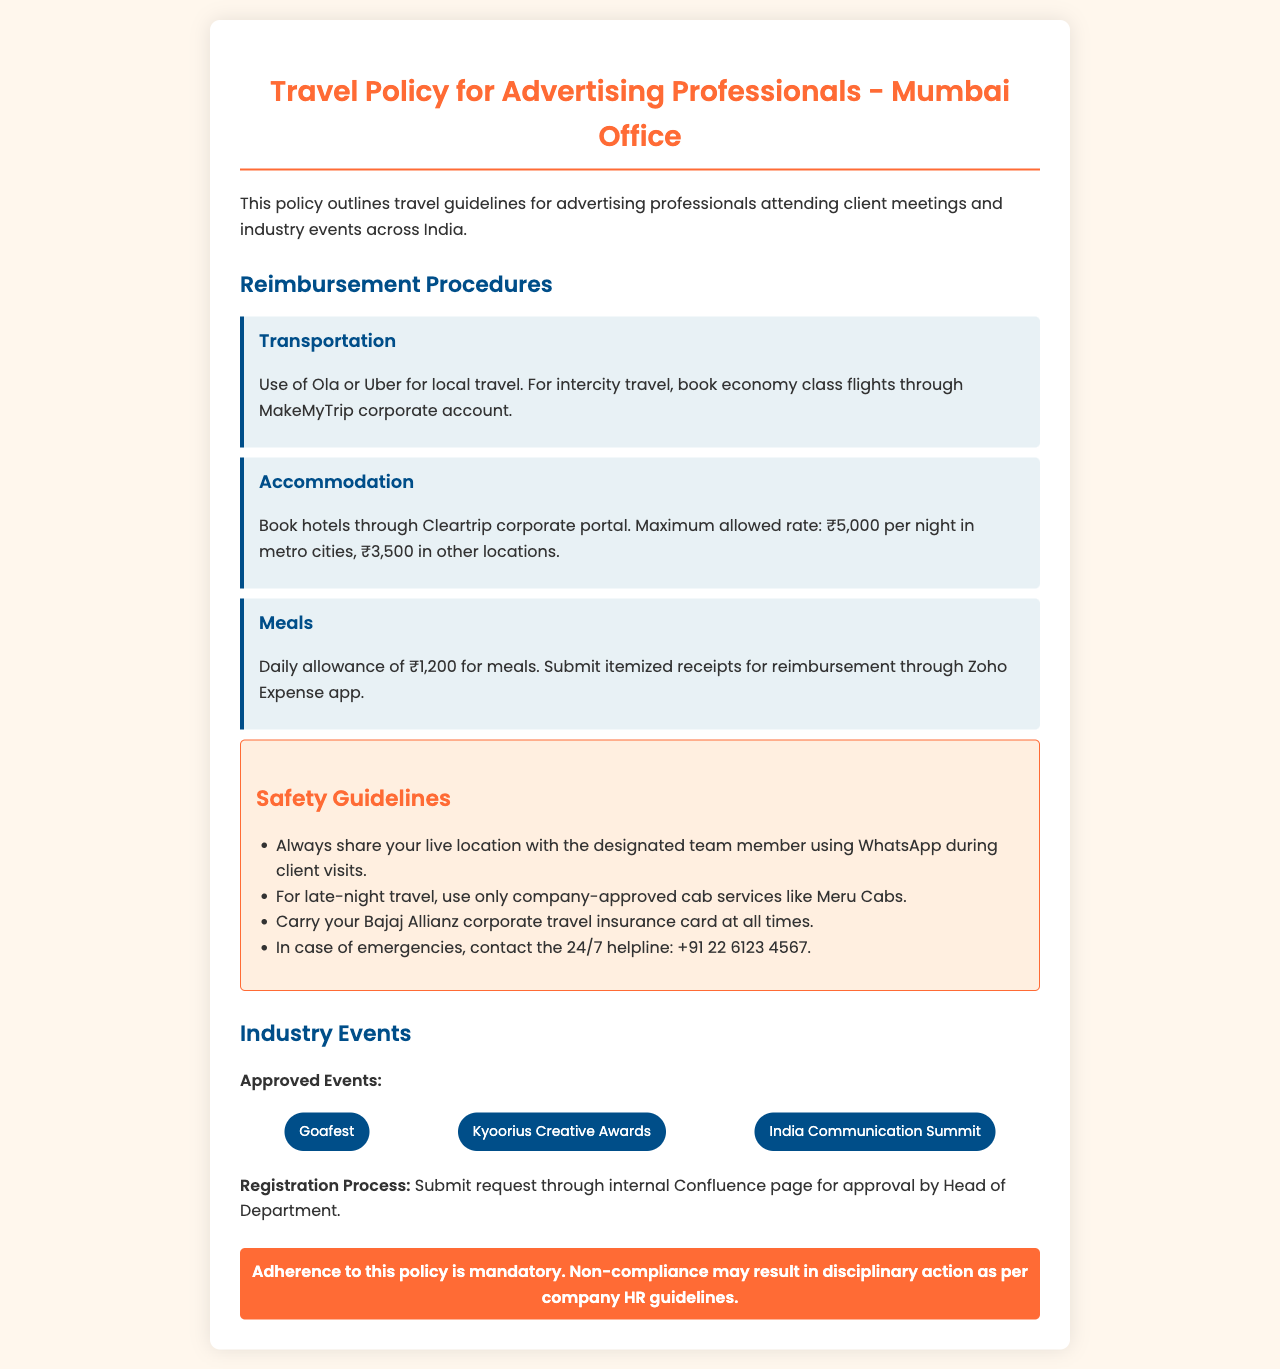What is the maximum allowed hotel rate in metro cities? The document specifies that the maximum allowed hotel rate in metro cities is ₹5,000 per night.
Answer: ₹5,000 What is the transportation method for intercity travel? The policy states to book economy class flights through the MakeMyTrip corporate account for intercity travel.
Answer: Economy class flights What is the daily allowance for meals? According to the document, the daily allowance for meals is ₹1,200.
Answer: ₹1,200 What should you do during client visits for safety? It is advised to always share your live location with the designated team member using WhatsApp during client visits.
Answer: Share your live location What is the process for event registration? The registration process requires submitting a request through the internal Confluence page for approval by the Head of Department.
Answer: Submit request through Confluence How much is the itemized meals receipts reimbursement processed through? The itemized meal receipts for reimbursement are submitted through the Zoho Expense app.
Answer: Zoho Expense app What type of insurance must be carried at all times? The document mentions that you must carry your Bajaj Allianz corporate travel insurance card at all times.
Answer: Bajaj Allianz corporate travel insurance card How many approved events are listed in the document? The document lists three approved events for attendance.
Answer: Three What is the 24/7 emergency contact number? The emergency contact number provided in the safety guidelines is +91 22 6123 4567.
Answer: +91 22 6123 4567 What may result from non-compliance with the travel policy? The document specifies that non-compliance may result in disciplinary action as per company HR guidelines.
Answer: Disciplinary action 